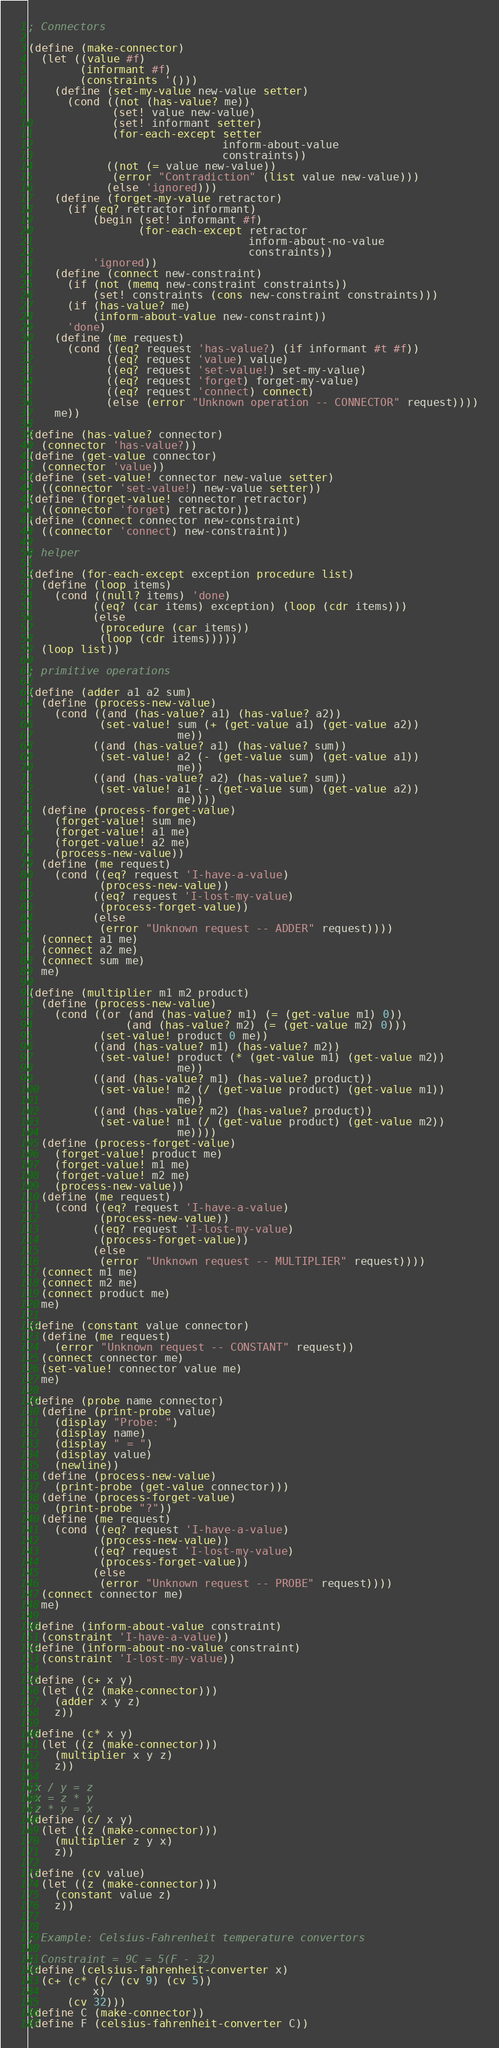Convert code to text. <code><loc_0><loc_0><loc_500><loc_500><_Scheme_>; Connectors

(define (make-connector)
  (let ((value #f)
        (informant #f)
        (constraints '()))
    (define (set-my-value new-value setter)
      (cond ((not (has-value? me))
             (set! value new-value)
             (set! informant setter)
             (for-each-except setter
                              inform-about-value
                              constraints))
            ((not (= value new-value))
             (error "Contradiction" (list value new-value)))
            (else 'ignored)))
    (define (forget-my-value retractor)
      (if (eq? retractor informant)
          (begin (set! informant #f)
                 (for-each-except retractor
                                  inform-about-no-value
                                  constraints))
          'ignored))
    (define (connect new-constraint)
      (if (not (memq new-constraint constraints))
          (set! constraints (cons new-constraint constraints)))
      (if (has-value? me)
          (inform-about-value new-constraint))
      'done)
    (define (me request)
      (cond ((eq? request 'has-value?) (if informant #t #f))
            ((eq? request 'value) value)
            ((eq? request 'set-value!) set-my-value)
            ((eq? request 'forget) forget-my-value)
            ((eq? request 'connect) connect)
            (else (error "Unknown operation -- CONNECTOR" request))))
    me))
      
(define (has-value? connector)
  (connector 'has-value?))
(define (get-value connector)
  (connector 'value))
(define (set-value! connector new-value setter)
  ((connector 'set-value!) new-value setter))
(define (forget-value! connector retractor)
  ((connector 'forget) retractor))
(define (connect connector new-constraint)
  ((connector 'connect) new-constraint))

; helper
  
(define (for-each-except exception procedure list)
  (define (loop items)
    (cond ((null? items) 'done)
          ((eq? (car items) exception) (loop (cdr items)))
          (else
           (procedure (car items))
           (loop (cdr items)))))
  (loop list))
  
; primitive operations

(define (adder a1 a2 sum)
  (define (process-new-value)
    (cond ((and (has-value? a1) (has-value? a2))
           (set-value! sum (+ (get-value a1) (get-value a2))
                       me))
          ((and (has-value? a1) (has-value? sum))
           (set-value! a2 (- (get-value sum) (get-value a1))
                       me))
          ((and (has-value? a2) (has-value? sum))
           (set-value! a1 (- (get-value sum) (get-value a2))
                       me))))
  (define (process-forget-value)
    (forget-value! sum me)
    (forget-value! a1 me)
    (forget-value! a2 me)
    (process-new-value))
  (define (me request)
    (cond ((eq? request 'I-have-a-value)
           (process-new-value))
          ((eq? request 'I-lost-my-value)
           (process-forget-value))
          (else
           (error "Unknown request -- ADDER" request))))
  (connect a1 me)
  (connect a2 me)
  (connect sum me)
  me)

(define (multiplier m1 m2 product)
  (define (process-new-value)
    (cond ((or (and (has-value? m1) (= (get-value m1) 0))
               (and (has-value? m2) (= (get-value m2) 0)))
           (set-value! product 0 me))
          ((and (has-value? m1) (has-value? m2))
           (set-value! product (* (get-value m1) (get-value m2))
                       me))
          ((and (has-value? m1) (has-value? product))
           (set-value! m2 (/ (get-value product) (get-value m1))
                       me))
          ((and (has-value? m2) (has-value? product))
           (set-value! m1 (/ (get-value product) (get-value m2))
                       me))))
  (define (process-forget-value)
    (forget-value! product me)
    (forget-value! m1 me)
    (forget-value! m2 me)
    (process-new-value))
  (define (me request)
    (cond ((eq? request 'I-have-a-value)
           (process-new-value))
          ((eq? request 'I-lost-my-value)
           (process-forget-value))
          (else
           (error "Unknown request -- MULTIPLIER" request))))
  (connect m1 me)
  (connect m2 me)
  (connect product me)
  me)

(define (constant value connector)
  (define (me request)
    (error "Unknown request -- CONSTANT" request))
  (connect connector me)
  (set-value! connector value me)
  me)

(define (probe name connector)
  (define (print-probe value)
    (display "Probe: ")
    (display name)
    (display " = ")
    (display value)
    (newline))
  (define (process-new-value)
    (print-probe (get-value connector)))
  (define (process-forget-value)
    (print-probe "?"))
  (define (me request)
    (cond ((eq? request 'I-have-a-value)
           (process-new-value))
          ((eq? request 'I-lost-my-value)
           (process-forget-value))
          (else
           (error "Unknown request -- PROBE" request))))
  (connect connector me)
  me)

(define (inform-about-value constraint)
  (constraint 'I-have-a-value))
(define (inform-about-no-value constraint)
  (constraint 'I-lost-my-value))

(define (c+ x y)
  (let ((z (make-connector)))
    (adder x y z)
    z))

(define (c* x y)
  (let ((z (make-connector)))
    (multiplier x y z)
    z))

;x / y = z
;x = z * y
;z * y = x
(define (c/ x y)
  (let ((z (make-connector)))
    (multiplier z y x)
    z))

(define (cv value)
  (let ((z (make-connector)))
    (constant value z)
    z))


; Example: Celsius-Fahrenheit temperature convertors

; Constraint = 9C = 5(F - 32)
(define (celsius-fahrenheit-converter x)
  (c+ (c* (c/ (cv 9) (cv 5))
          x)
      (cv 32)))
(define C (make-connector))
(define F (celsius-fahrenheit-converter C))
</code> 